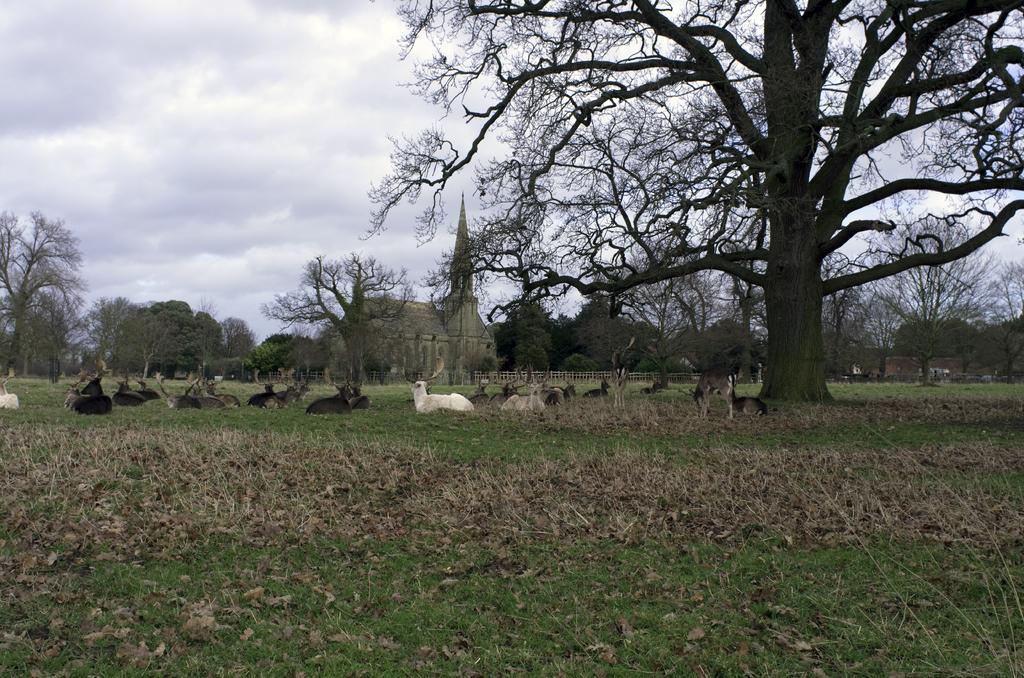What is the main feature in the image? There is a huge tree in the image. What are the animals doing in the image? Many animals are laying on the grass under the tree. What can be seen behind the garden? There is a building behind the garden. What is the surrounding environment like? There are plenty of trees around the building. How many eggs are being carried by the stranger in the image? There is no stranger present in the image, and therefore no eggs being carried. Can you describe the snail's shell in the image? There is no snail present in the image, so its shell cannot be described. 